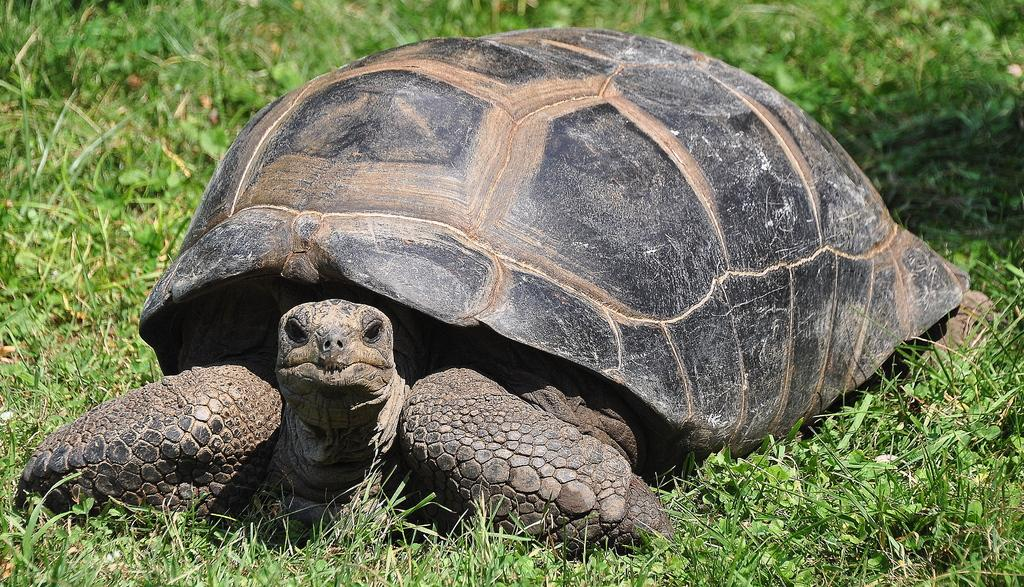What type of animal is in the image? There is a tortoise in the image. Where is the tortoise located? The tortoise is on the grass. What type of tools does the carpenter use in the image? There is no carpenter present in the image, so it is not possible to answer that question. 